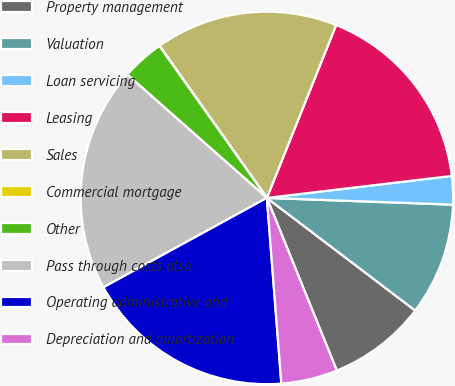Convert chart to OTSL. <chart><loc_0><loc_0><loc_500><loc_500><pie_chart><fcel>Property management<fcel>Valuation<fcel>Loan servicing<fcel>Leasing<fcel>Sales<fcel>Commercial mortgage<fcel>Other<fcel>Pass through costs also<fcel>Operating administrative and<fcel>Depreciation and amortization<nl><fcel>8.54%<fcel>9.76%<fcel>2.46%<fcel>17.05%<fcel>15.84%<fcel>0.03%<fcel>3.68%<fcel>19.49%<fcel>18.27%<fcel>4.89%<nl></chart> 